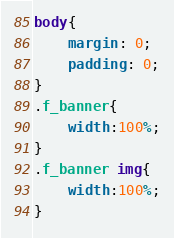Convert code to text. <code><loc_0><loc_0><loc_500><loc_500><_CSS_>body{
	margin: 0;
	padding: 0;
}
.f_banner{
	width:100%;
}
.f_banner img{
	width:100%;
}
</code> 